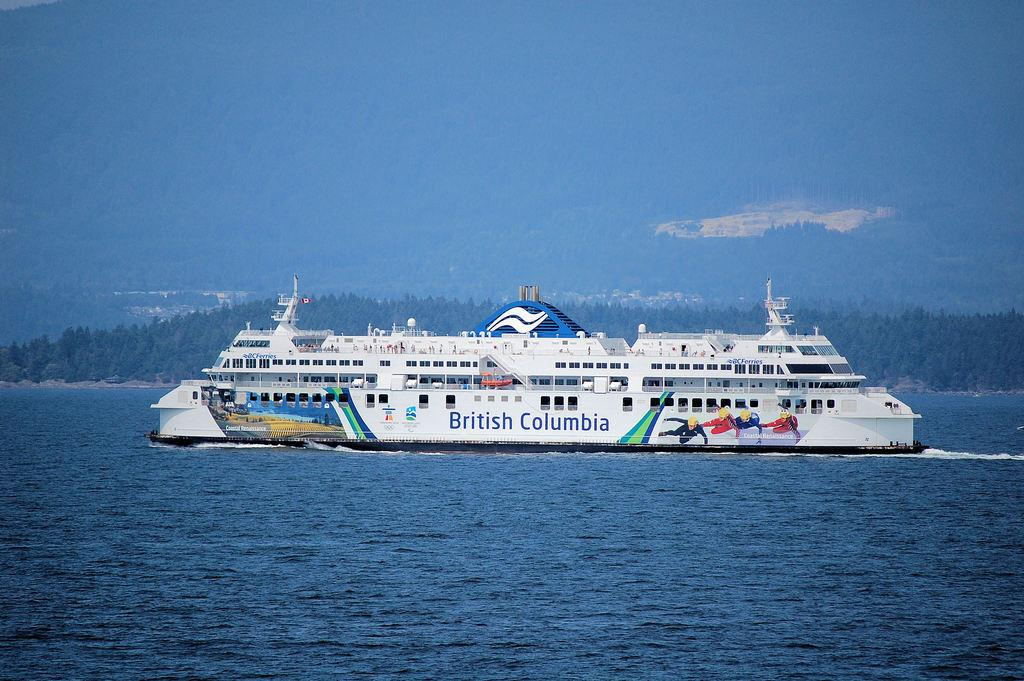<image>
Share a concise interpretation of the image provided. A white cruise ship that is advertising British Columbia on the side. 